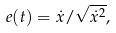<formula> <loc_0><loc_0><loc_500><loc_500>e ( t ) = \dot { x } / \sqrt { \dot { x } ^ { 2 } } ,</formula> 